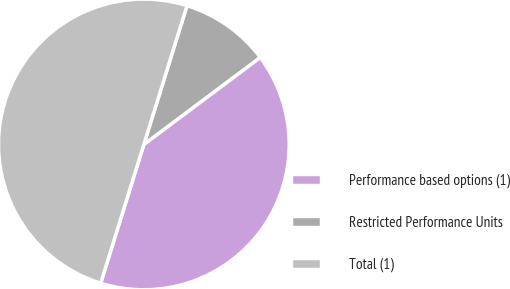Convert chart. <chart><loc_0><loc_0><loc_500><loc_500><pie_chart><fcel>Performance based options (1)<fcel>Restricted Performance Units<fcel>Total (1)<nl><fcel>40.02%<fcel>9.98%<fcel>50.0%<nl></chart> 